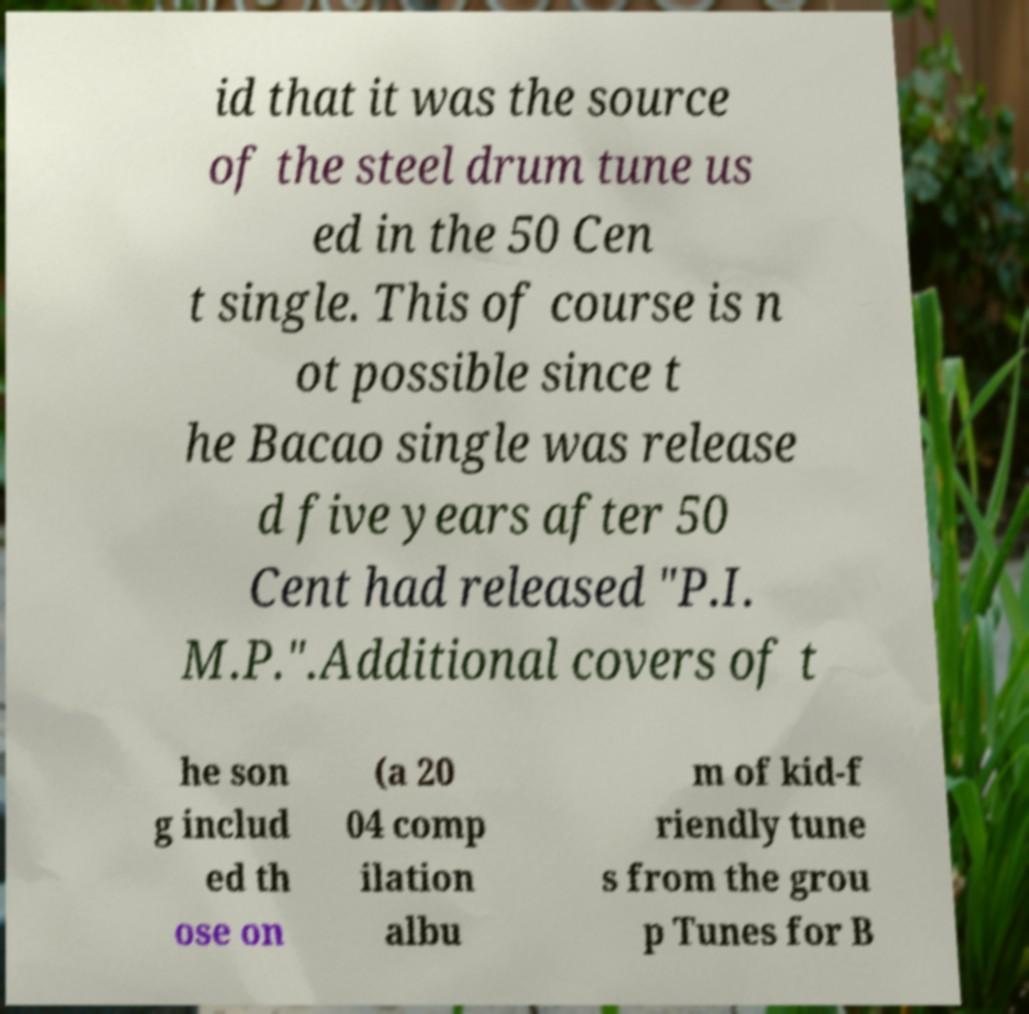Please read and relay the text visible in this image. What does it say? id that it was the source of the steel drum tune us ed in the 50 Cen t single. This of course is n ot possible since t he Bacao single was release d five years after 50 Cent had released "P.I. M.P.".Additional covers of t he son g includ ed th ose on (a 20 04 comp ilation albu m of kid-f riendly tune s from the grou p Tunes for B 